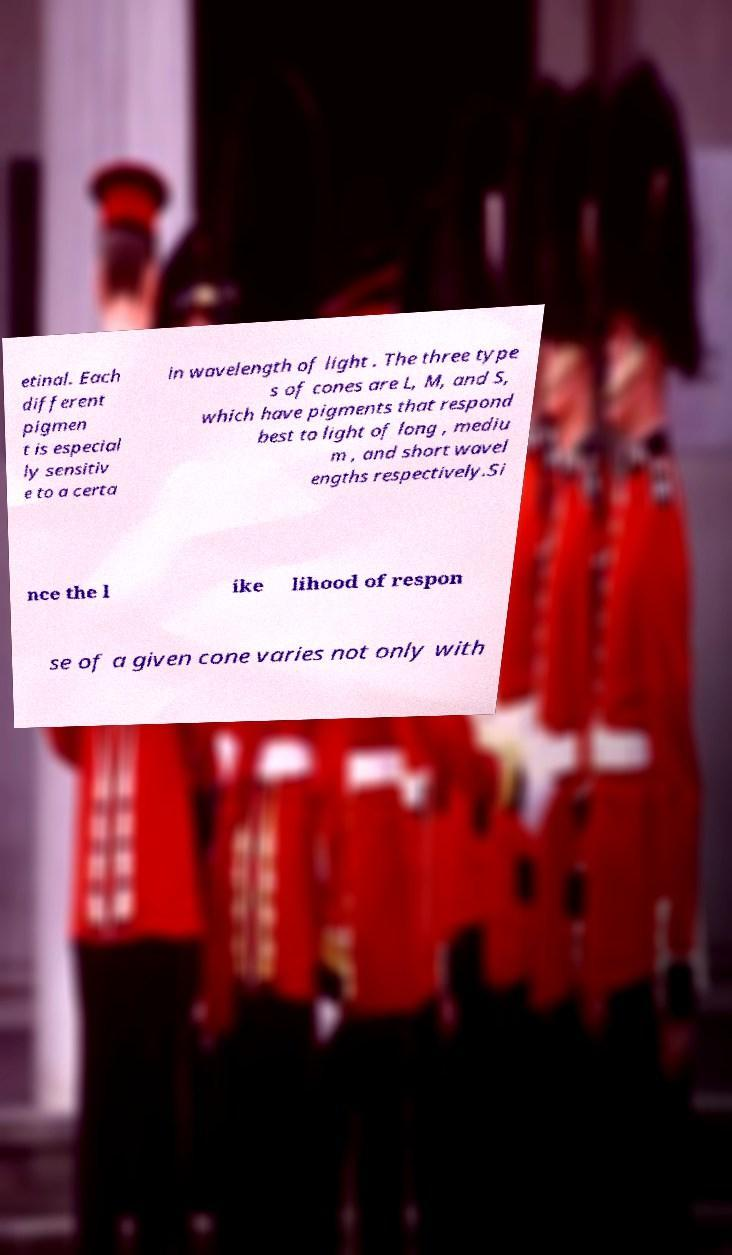I need the written content from this picture converted into text. Can you do that? etinal. Each different pigmen t is especial ly sensitiv e to a certa in wavelength of light . The three type s of cones are L, M, and S, which have pigments that respond best to light of long , mediu m , and short wavel engths respectively.Si nce the l ike lihood of respon se of a given cone varies not only with 